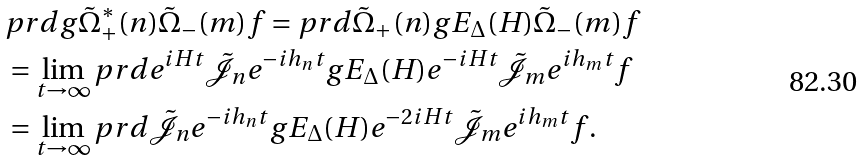<formula> <loc_0><loc_0><loc_500><loc_500>& p r d { g } { \tilde { \Omega } _ { + } ^ { * } ( n ) \tilde { \Omega } _ { - } ( m ) f } = p r d { \tilde { \Omega } _ { + } ( n ) g } { E _ { \Delta } ( H ) \tilde { \Omega } _ { - } ( m ) f } \\ & = \lim _ { t \to \infty } p r d { e ^ { i H t } \tilde { \mathcal { J } } _ { n } e ^ { - i h _ { n } t } g } { E _ { \Delta } ( H ) e ^ { - i H t } \tilde { \mathcal { J } } _ { m } e ^ { i h _ { m } t } f } \\ & = \lim _ { t \to \infty } p r d { \tilde { \mathcal { J } } _ { n } e ^ { - i h _ { n } t } g } { E _ { \Delta } ( H ) e ^ { - 2 i H t } \tilde { \mathcal { J } } _ { m } e ^ { i h _ { m } t } f } .</formula> 